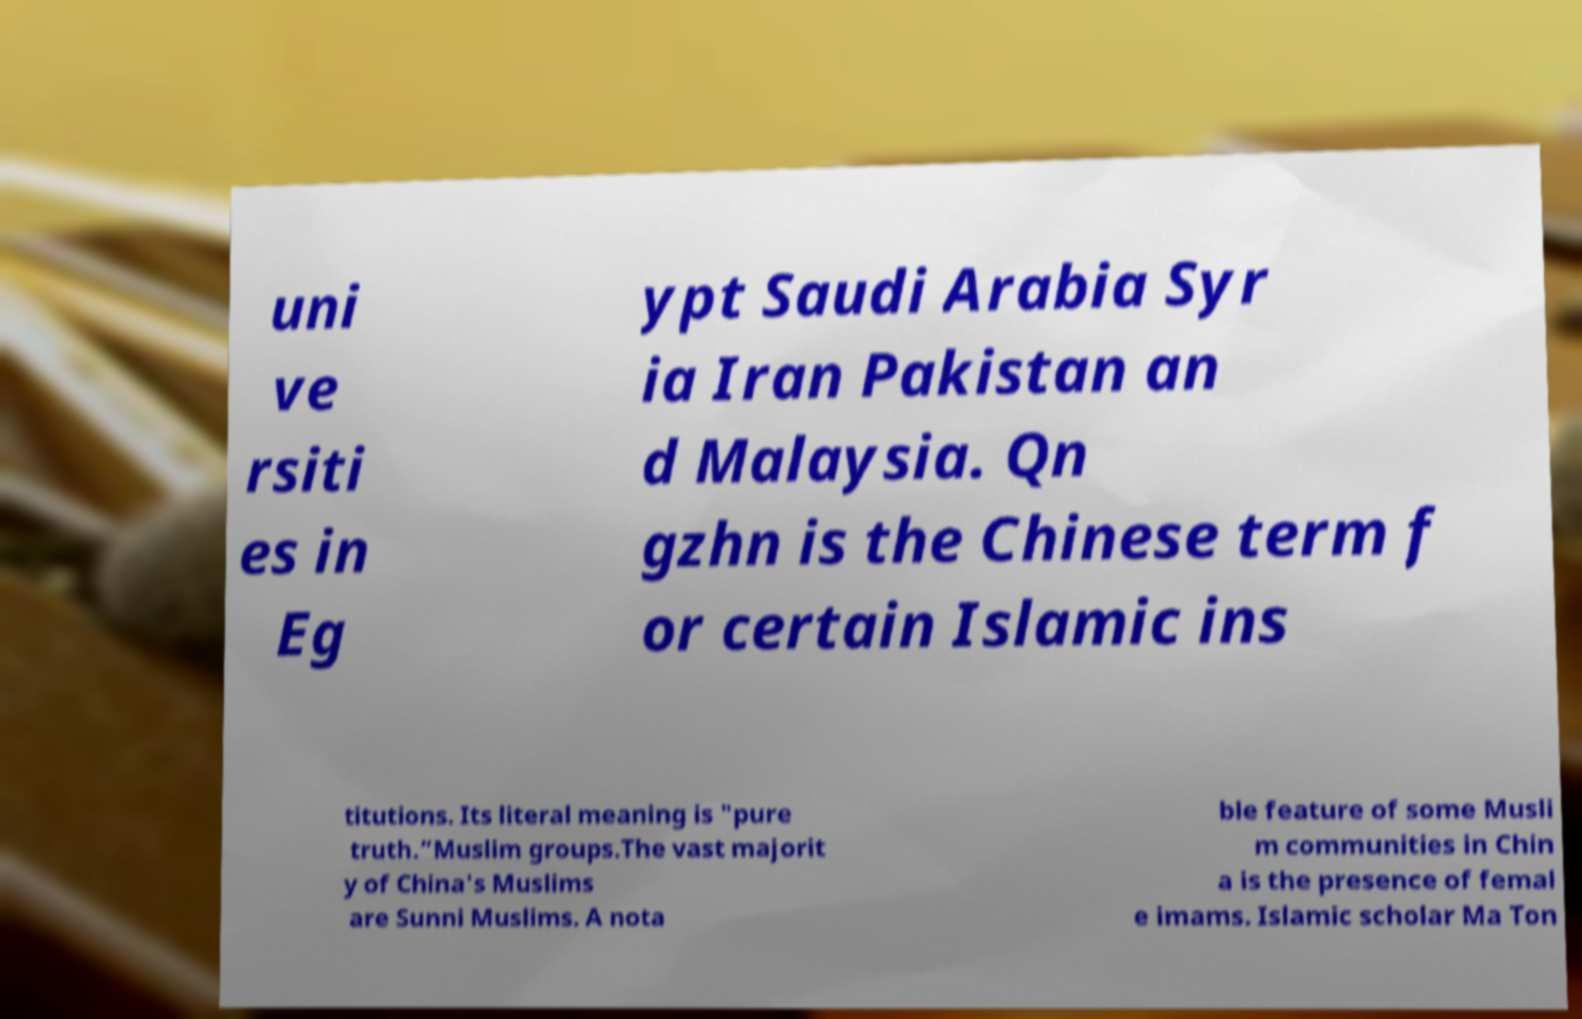I need the written content from this picture converted into text. Can you do that? uni ve rsiti es in Eg ypt Saudi Arabia Syr ia Iran Pakistan an d Malaysia. Qn gzhn is the Chinese term f or certain Islamic ins titutions. Its literal meaning is "pure truth.”Muslim groups.The vast majorit y of China's Muslims are Sunni Muslims. A nota ble feature of some Musli m communities in Chin a is the presence of femal e imams. Islamic scholar Ma Ton 